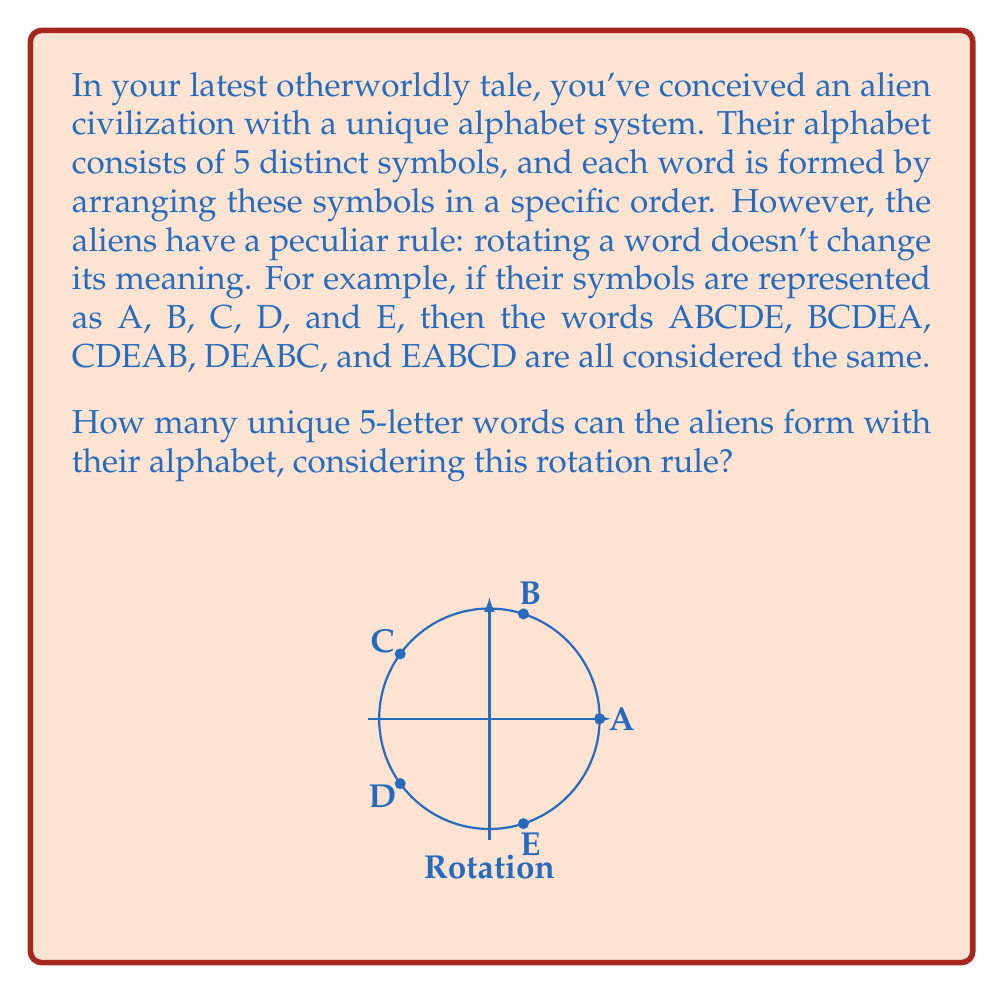What is the answer to this math problem? Let's approach this problem step-by-step using group theory and permutations:

1) First, we need to recognize that this problem involves cyclic groups. The rotation of words forms a cyclic group of order 5.

2) The total number of permutations of 5 symbols is 5! = 120. This would be our answer if rotations were considered distinct.

3) However, each unique word under the rotation rule is actually an equivalence class containing 5 rotations (as there are 5 symbols).

4) In group theory terms, we're looking for the number of orbits under the action of the cyclic group C_5 on the set of all permutations.

5) We can use Burnside's lemma to solve this. Let X be the set of all permutations, and G be the cyclic group of order 5. Burnside's lemma states:

   $$ |X/G| = \frac{1}{|G|} \sum_{g \in G} |X^g| $$

   where $|X/G|$ is the number of orbits, and $|X^g|$ is the number of elements fixed by g.

6) In our case:
   - $|G| = 5$
   - The identity element fixes all 120 permutations
   - The other 4 rotations fix no permutations (as rotating a permutation always changes it unless it's a full rotation)

7) Applying Burnside's lemma:

   $$ |X/G| = \frac{1}{5} (120 + 0 + 0 + 0 + 0) = 24 $$

Therefore, there are 24 unique words under this rotation rule.
Answer: 24 unique words 